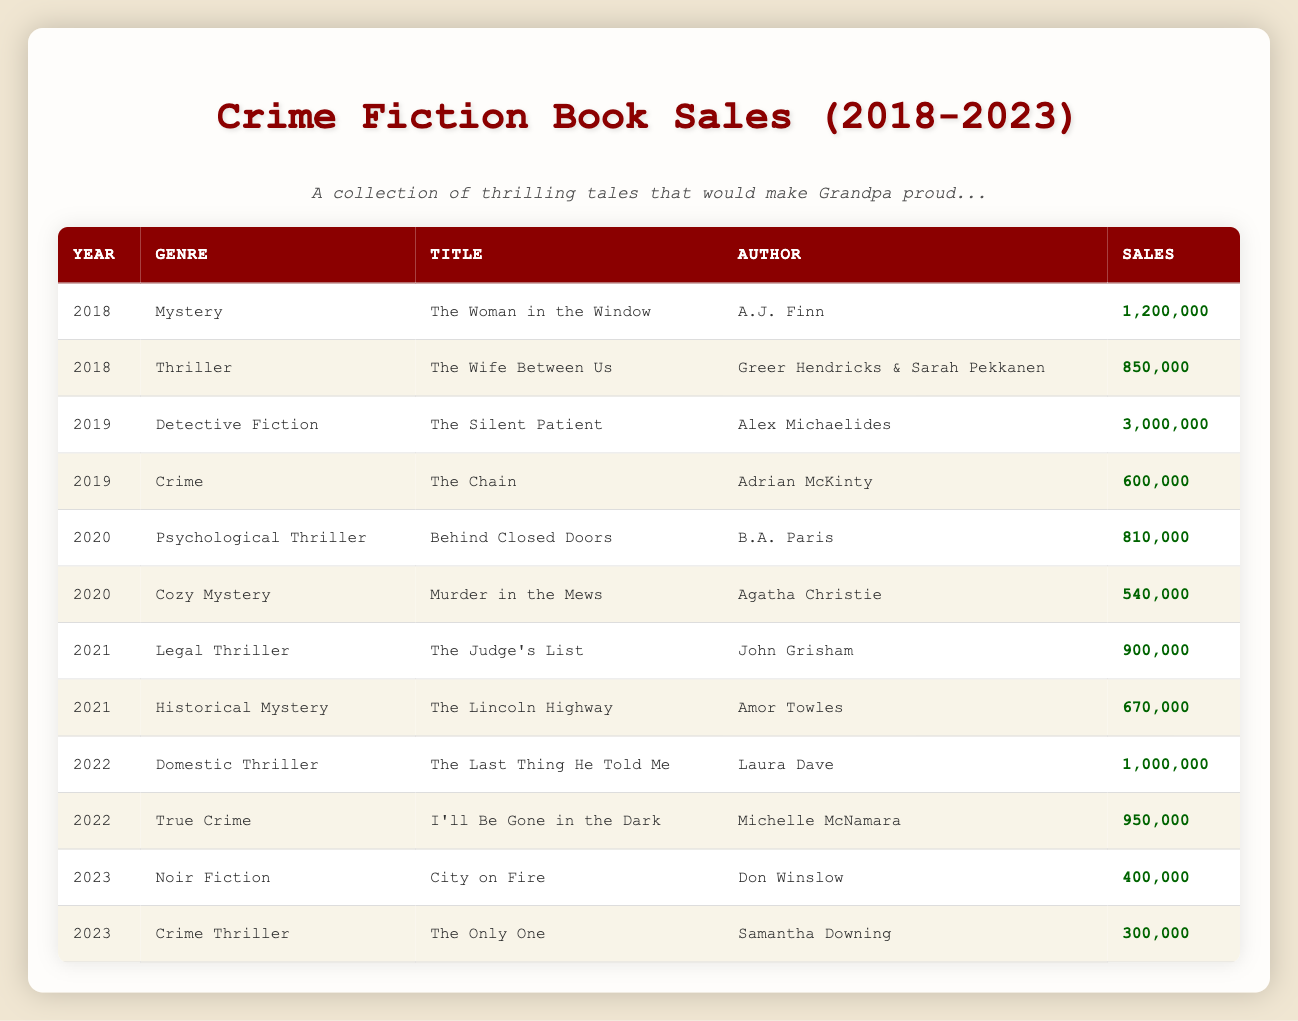What is the title of the book with the highest sales in 2019? In 2019, the books listed are "The Silent Patient" with 3,000,000 sales and "The Chain" with 600,000 sales. "The Silent Patient" has the highest sales.
Answer: The Silent Patient Which genre had the lowest sales in 2020? In 2020, the genres listed are Psychological Thriller with 810,000 sales and Cozy Mystery with 540,000 sales. "Murder in the Mews" (Cozy Mystery) had the lowest sales of 540,000.
Answer: Cozy Mystery Did "I'll Be Gone in the Dark" surpass 1 million in sales? "I'll Be Gone in the Dark" has 950,000 sales, which is below 1 million.
Answer: No What is the total sales of Legal Thriller and Historical Mystery combined in 2021? The sales for Legal Thriller ("The Judge's List") is 900,000 and for Historical Mystery ("The Lincoln Highway") is 670,000. Summing these gives 900,000 + 670,000 = 1,570,000.
Answer: 1,570,000 Which year saw a release of a “Noir Fiction” book and how many copies were sold? A "Noir Fiction" book titled "City on Fire" was released in 2023 with sales of 400,000.
Answer: 2023, 400,000 What is the average sales for the books released in 2022? The books released in 2022 are "The Last Thing He Told Me" (1,000,000) and "I'll Be Gone in the Dark" (950,000). Summing these gives 1,000,000 + 950,000 = 1,950,000, and dividing by 2 gives an average of 975,000.
Answer: 975,000 Is there any book from the table that sold more than 2 million copies? "The Silent Patient" sold 3,000,000 copies, which is over 2 million.
Answer: Yes How many different genres had sales over 800,000 in 2019? In 2019, "The Silent Patient" (3,000,000) and "The Chain" (600,000) were released. The only genre with sales over 800,000 is "Detective Fiction."
Answer: 1 